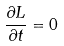Convert formula to latex. <formula><loc_0><loc_0><loc_500><loc_500>\frac { \partial L } { \partial t } = 0</formula> 